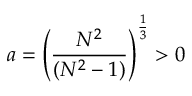<formula> <loc_0><loc_0><loc_500><loc_500>a = \left ( \frac { N ^ { 2 } } { ( N ^ { 2 } - 1 ) } \right ) ^ { \frac { 1 } { 3 } } > 0</formula> 